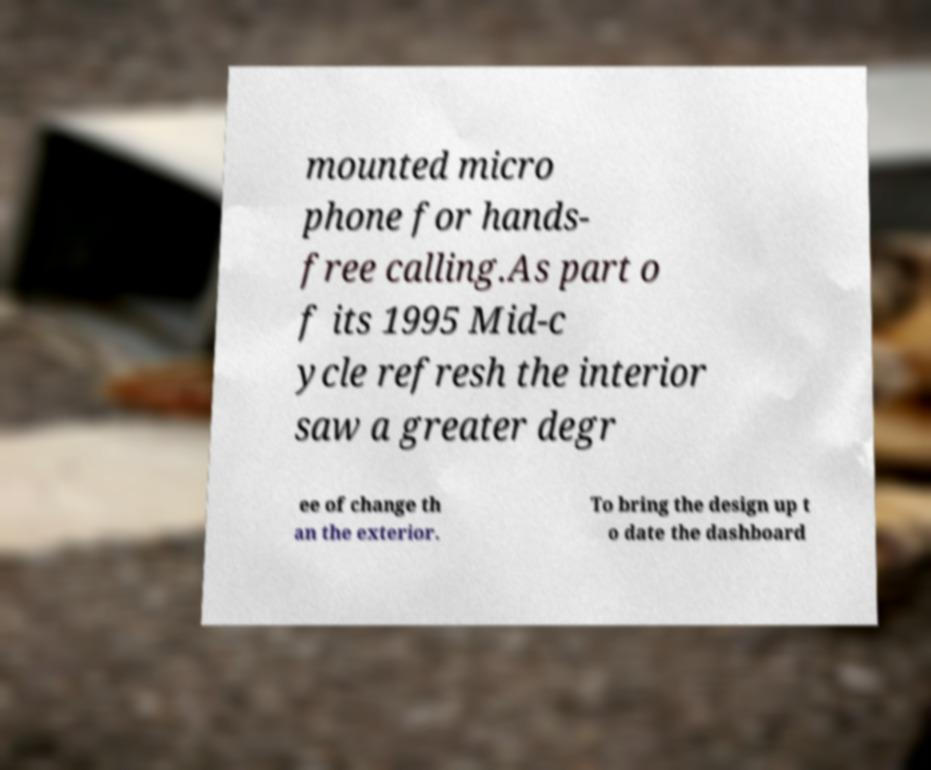Please read and relay the text visible in this image. What does it say? mounted micro phone for hands- free calling.As part o f its 1995 Mid-c ycle refresh the interior saw a greater degr ee of change th an the exterior. To bring the design up t o date the dashboard 